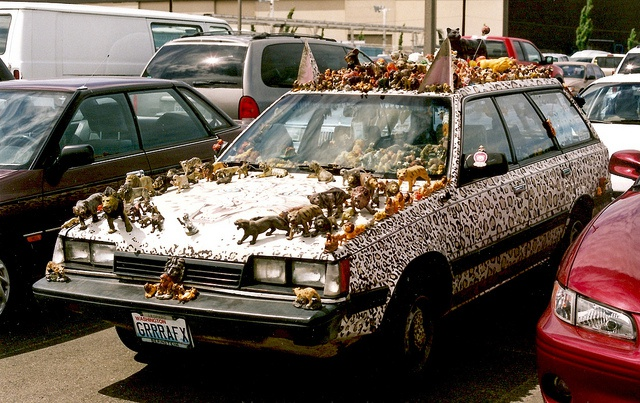Describe the objects in this image and their specific colors. I can see car in black, white, darkgray, and gray tones, car in black, darkgray, gray, and darkgreen tones, car in black, brown, and maroon tones, truck in black, lightgray, darkgray, and gray tones, and car in black, lightgray, darkgray, and gray tones in this image. 